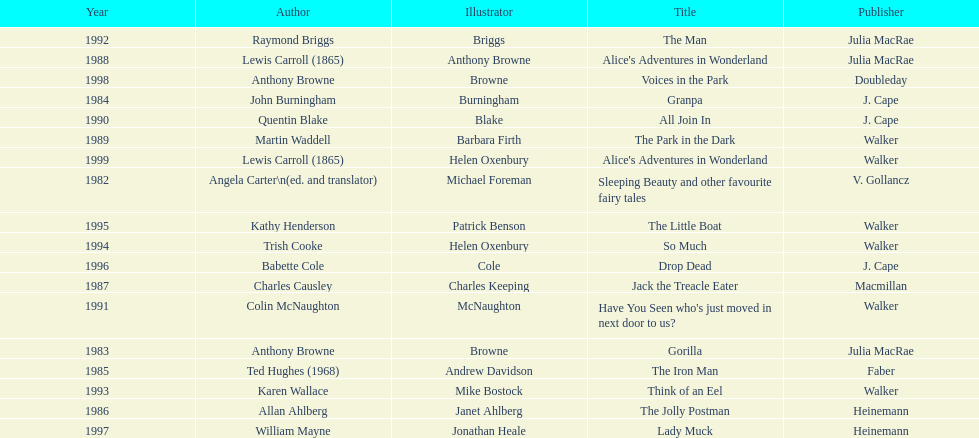Would you mind parsing the complete table? {'header': ['Year', 'Author', 'Illustrator', 'Title', 'Publisher'], 'rows': [['1992', 'Raymond Briggs', 'Briggs', 'The Man', 'Julia MacRae'], ['1988', 'Lewis Carroll (1865)', 'Anthony Browne', "Alice's Adventures in Wonderland", 'Julia MacRae'], ['1998', 'Anthony Browne', 'Browne', 'Voices in the Park', 'Doubleday'], ['1984', 'John Burningham', 'Burningham', 'Granpa', 'J. Cape'], ['1990', 'Quentin Blake', 'Blake', 'All Join In', 'J. Cape'], ['1989', 'Martin Waddell', 'Barbara Firth', 'The Park in the Dark', 'Walker'], ['1999', 'Lewis Carroll (1865)', 'Helen Oxenbury', "Alice's Adventures in Wonderland", 'Walker'], ['1982', 'Angela Carter\\n(ed. and translator)', 'Michael Foreman', 'Sleeping Beauty and other favourite fairy tales', 'V. Gollancz'], ['1995', 'Kathy Henderson', 'Patrick Benson', 'The Little Boat', 'Walker'], ['1994', 'Trish Cooke', 'Helen Oxenbury', 'So Much', 'Walker'], ['1996', 'Babette Cole', 'Cole', 'Drop Dead', 'J. Cape'], ['1987', 'Charles Causley', 'Charles Keeping', 'Jack the Treacle Eater', 'Macmillan'], ['1991', 'Colin McNaughton', 'McNaughton', "Have You Seen who's just moved in next door to us?", 'Walker'], ['1983', 'Anthony Browne', 'Browne', 'Gorilla', 'Julia MacRae'], ['1985', 'Ted Hughes (1968)', 'Andrew Davidson', 'The Iron Man', 'Faber'], ['1993', 'Karen Wallace', 'Mike Bostock', 'Think of an Eel', 'Walker'], ['1986', 'Allan Ahlberg', 'Janet Ahlberg', 'The Jolly Postman', 'Heinemann'], ['1997', 'William Mayne', 'Jonathan Heale', 'Lady Muck', 'Heinemann']]} Which other author, besides lewis carroll, has won the kurt maschler award twice? Anthony Browne. 